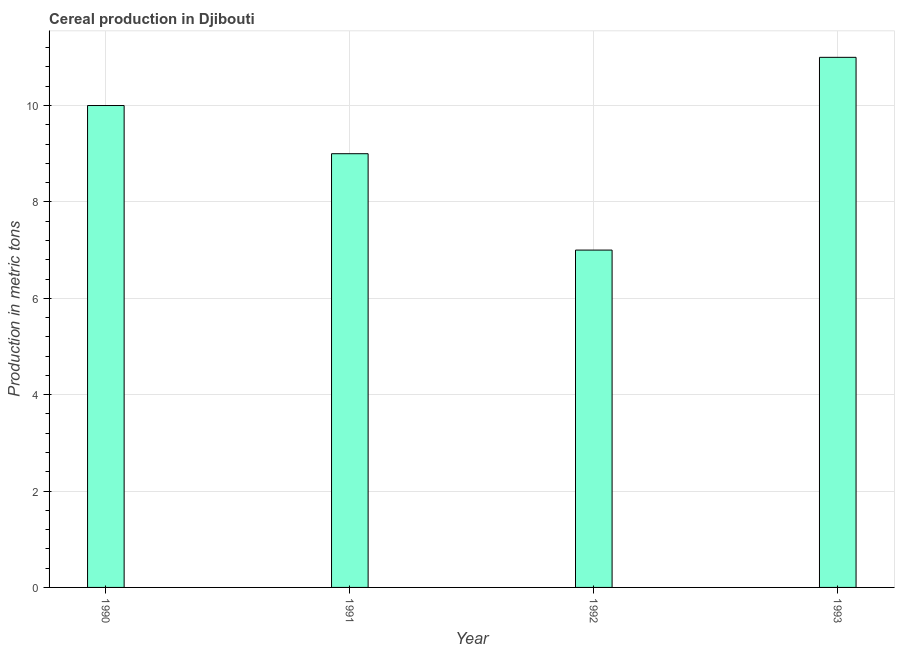Does the graph contain grids?
Keep it short and to the point. Yes. What is the title of the graph?
Offer a very short reply. Cereal production in Djibouti. What is the label or title of the X-axis?
Keep it short and to the point. Year. What is the label or title of the Y-axis?
Ensure brevity in your answer.  Production in metric tons. What is the cereal production in 1993?
Provide a short and direct response. 11. Across all years, what is the maximum cereal production?
Give a very brief answer. 11. Across all years, what is the minimum cereal production?
Offer a very short reply. 7. In which year was the cereal production maximum?
Provide a succinct answer. 1993. What is the sum of the cereal production?
Provide a succinct answer. 37. What is the difference between the cereal production in 1990 and 1993?
Give a very brief answer. -1. What is the average cereal production per year?
Your answer should be very brief. 9. What is the ratio of the cereal production in 1990 to that in 1991?
Provide a succinct answer. 1.11. Is the cereal production in 1990 less than that in 1991?
Ensure brevity in your answer.  No. Is the difference between the cereal production in 1990 and 1993 greater than the difference between any two years?
Offer a terse response. No. Is the sum of the cereal production in 1991 and 1993 greater than the maximum cereal production across all years?
Provide a short and direct response. Yes. What is the difference between the highest and the lowest cereal production?
Give a very brief answer. 4. In how many years, is the cereal production greater than the average cereal production taken over all years?
Offer a very short reply. 2. How many bars are there?
Your response must be concise. 4. What is the difference between two consecutive major ticks on the Y-axis?
Your answer should be very brief. 2. Are the values on the major ticks of Y-axis written in scientific E-notation?
Provide a succinct answer. No. What is the Production in metric tons in 1991?
Your answer should be compact. 9. What is the difference between the Production in metric tons in 1990 and 1992?
Your answer should be very brief. 3. What is the ratio of the Production in metric tons in 1990 to that in 1991?
Ensure brevity in your answer.  1.11. What is the ratio of the Production in metric tons in 1990 to that in 1992?
Offer a terse response. 1.43. What is the ratio of the Production in metric tons in 1990 to that in 1993?
Offer a terse response. 0.91. What is the ratio of the Production in metric tons in 1991 to that in 1992?
Offer a terse response. 1.29. What is the ratio of the Production in metric tons in 1991 to that in 1993?
Ensure brevity in your answer.  0.82. What is the ratio of the Production in metric tons in 1992 to that in 1993?
Offer a terse response. 0.64. 